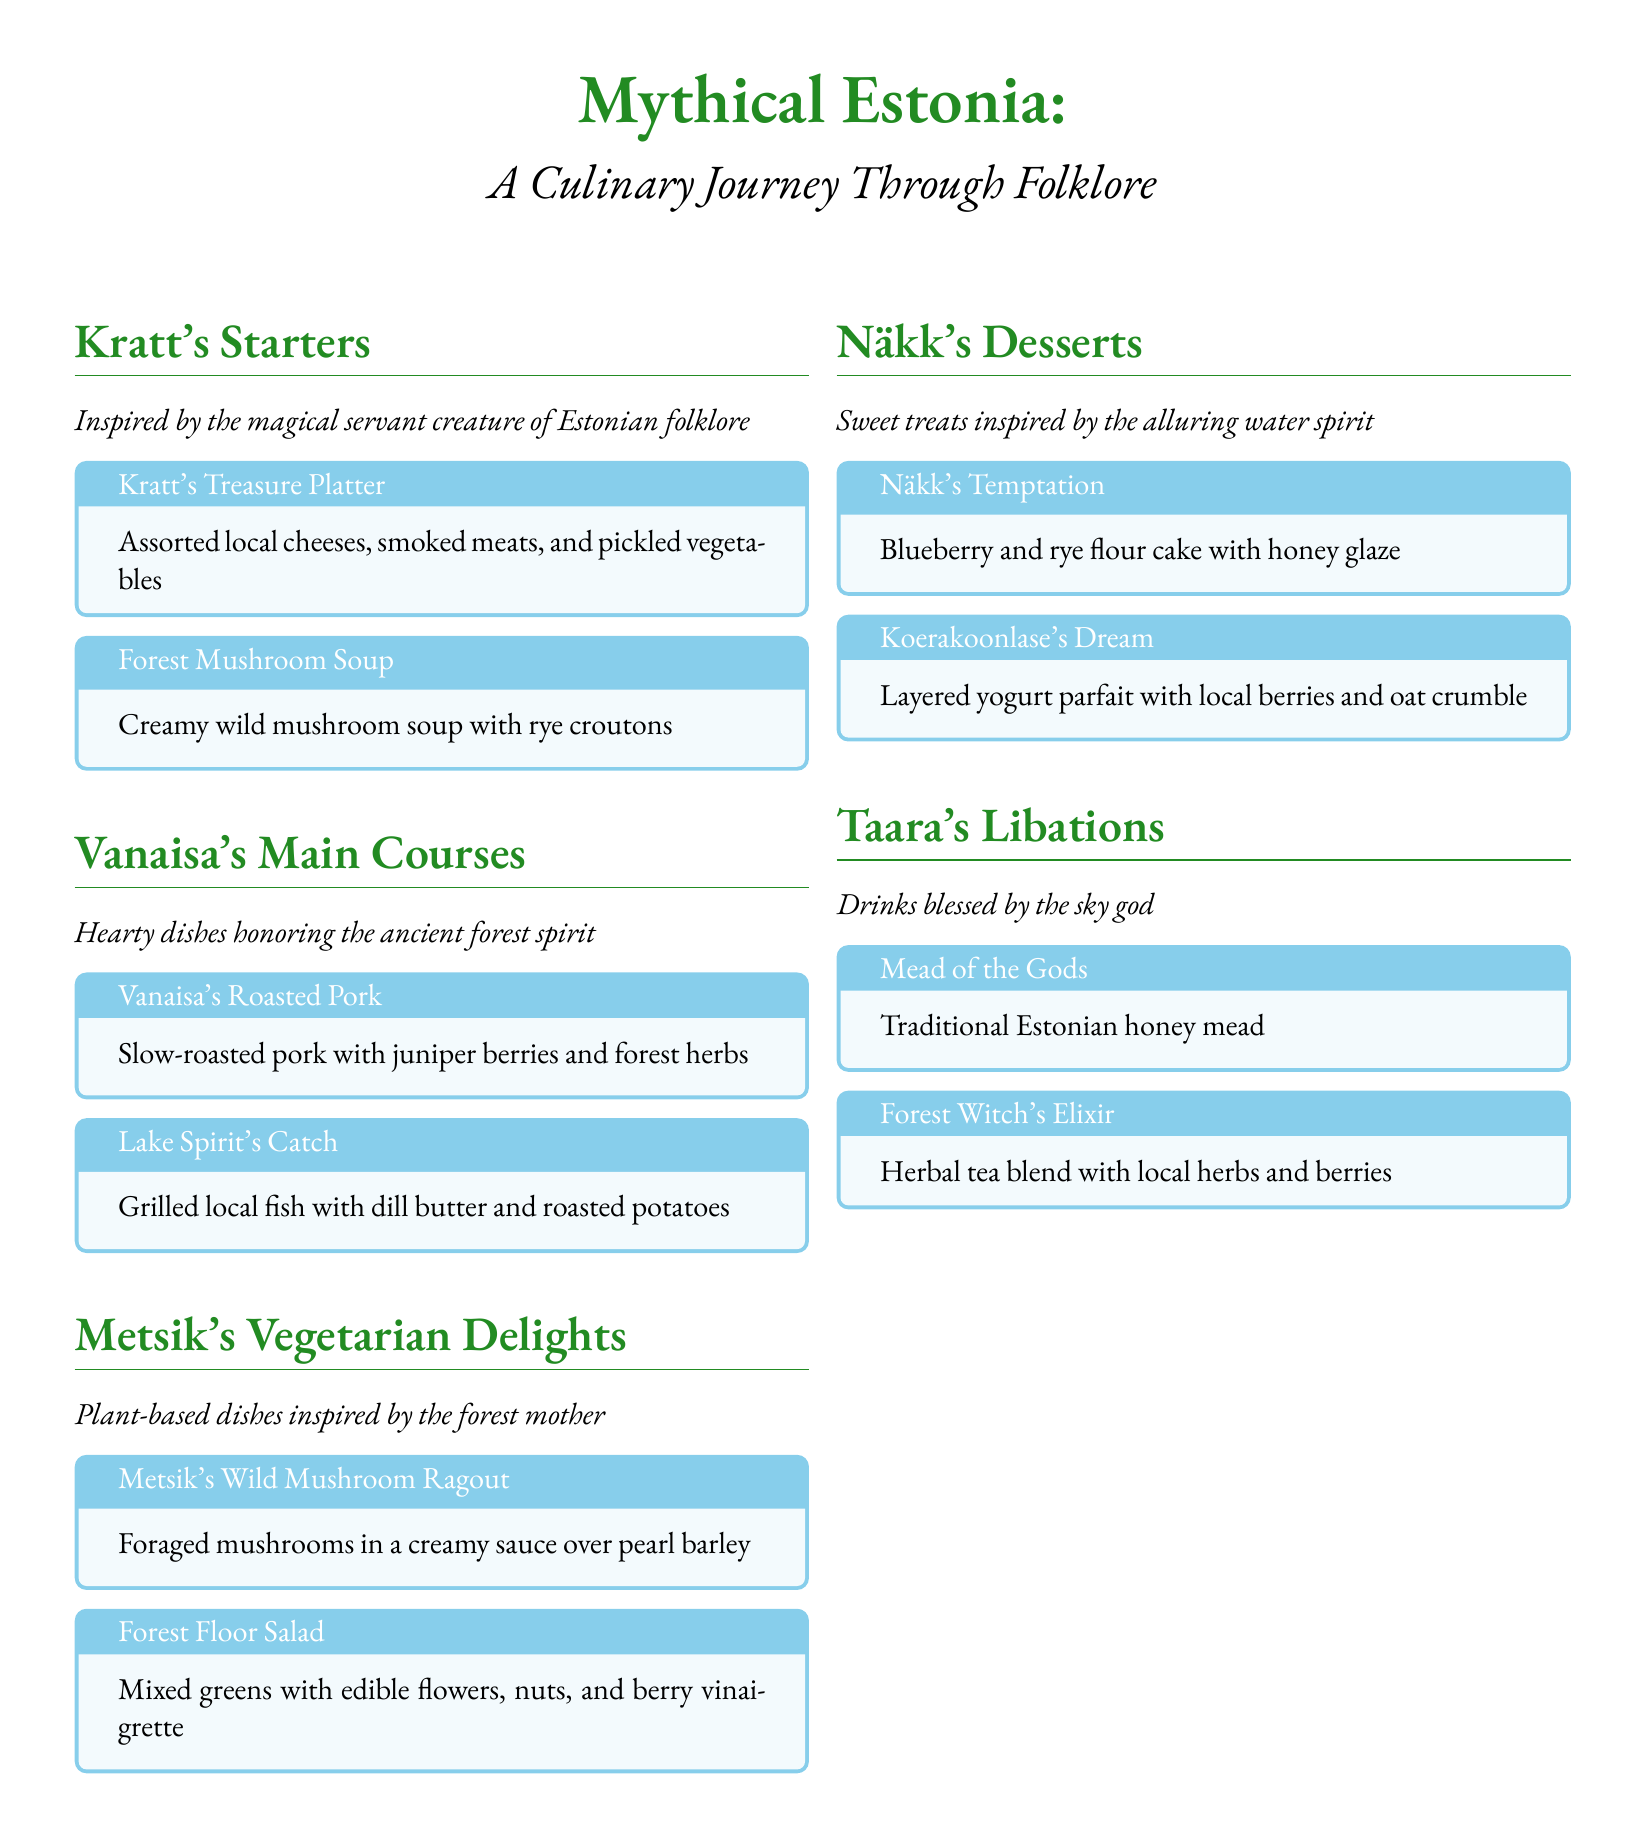What is the title of the menu? The title of the menu is prominently displayed at the top of the document, indicating the theme and purpose of the menu.
Answer: Mythical Estonia: A Culinary Journey Through Folklore What inspired the Kratt's Starters section? Each section is inspired by specific mythical creatures from Estonian folklore, and the Kratt's Starters are inspired by a magical servant.
Answer: Kratt What is included in the Kratt's Treasure Platter? The contents of the platter are described in the box pertaining to Kratt's Treasure Platter, framing the dish as a unique offering.
Answer: Assorted local cheeses, smoked meats, and pickled vegetables Which dish is inspired by the ancient forest spirit? This question pertains to the section on main courses where dishes are dedicated to various forest entities, highlighting the key character behind the main course.
Answer: Vanaisa's Roasted Pork What dessert features blueberry and rye flour? The answer can be found in the dessert section, specifying the dessert that prominently features these ingredients in its title.
Answer: Näkk's Temptation What type of drink is the Mead of the Gods? The nature of the drink is defined in the libations section, with a title that suggests its significance and origins.
Answer: Traditional Estonian honey mead How many sections are in the menu? The menu is divided into specific thematic sections that align with various aspects of Estonian mythology and culinary offerings.
Answer: Five What is included in the Forest Floor Salad? This dish is detailed in the vegetarian delights section, providing insight into its ingredients directly from the description.
Answer: Mixed greens with edible flowers, nuts, and berry vinaigrette 